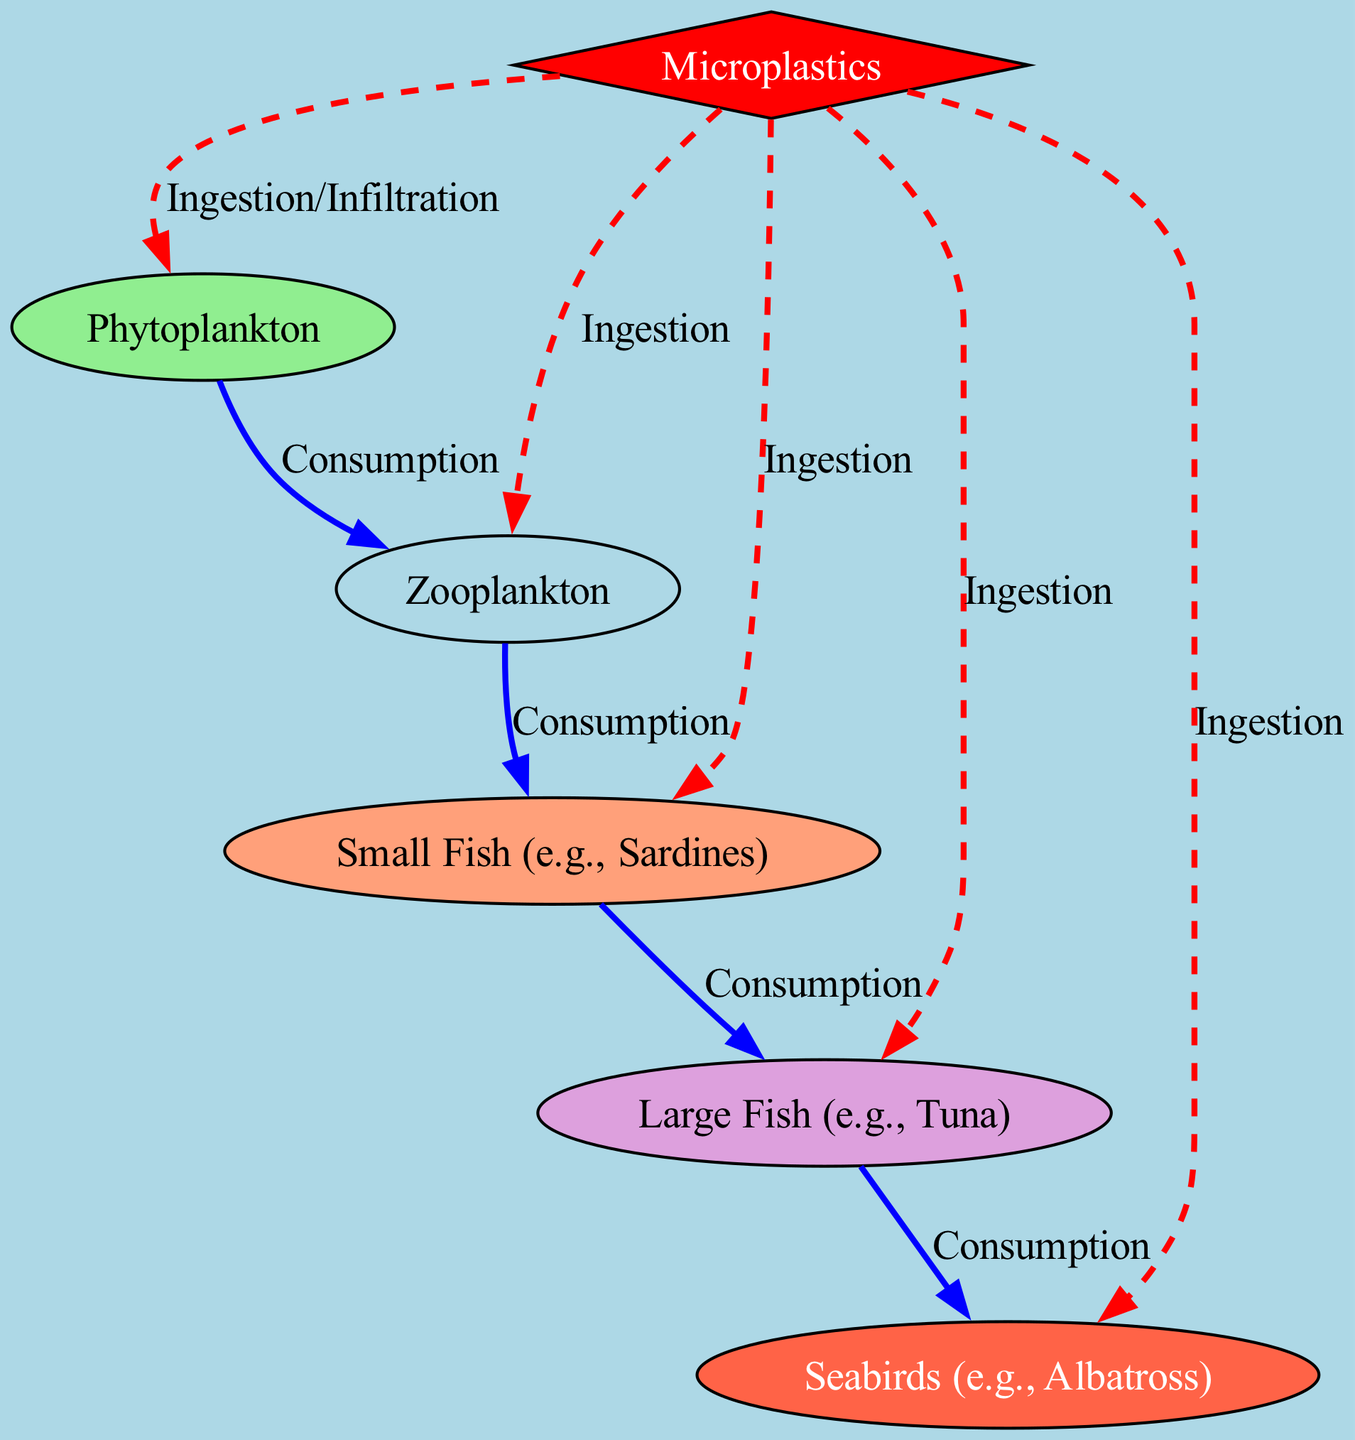What is the first node in the food chain? The diagram starts with phytoplankton, which is positioned at the top as the primary producer. It is the starting point of the food chain represented.
Answer: Phytoplankton How many edges represent predation in the diagram? By counting the edges labeled as 'Consumption', we find there are four edges connecting the different levels of the food chain, which signifies predation.
Answer: 4 What type of pollutant is shown in the diagram? The diagram depicts microplastics as the pollutant affecting the food chain. It is classified as a pollutant node and is distinctly colored red.
Answer: Microplastics Which apex predator is shown in the diagram? The top of the food chain is represented by seabirds, specifically albatross, and is positioned at the end of the chain. This indicates its role as an apex predator in the ecosystem.
Answer: Seabirds What is the relationship between zooplankton and small fish? The relationship is one of consumption, indicated by an edge labeled 'Consumption', which signifies that zooplankton are a food source for small fish.
Answer: Consumption Which node is directly impacted by plastic particles besides phytoplankton? Looking at the edges originating from plastic particles, we see that both zooplankton and small fish are directly impacted, as they also show an 'Ingestion' connection.
Answer: Zooplankton What color represents tertiary consumers in the diagram? The tertiary consumers, which include large fish, are represented by a light purple shade, denoting their position in the food chain.
Answer: Light Purple How do plastic particles affect large fish? The diagram shows that large fish can ingest plastic particles, which is portrayed through a dashed red line labeled 'Ingestion', indicating disruption in the food chain.
Answer: Ingestion What type of consumers are small fish in the diagram? Small fish are categorized as secondary consumers in the food chain, meaning they consume primary consumers like zooplankton.
Answer: Secondary Consumers 